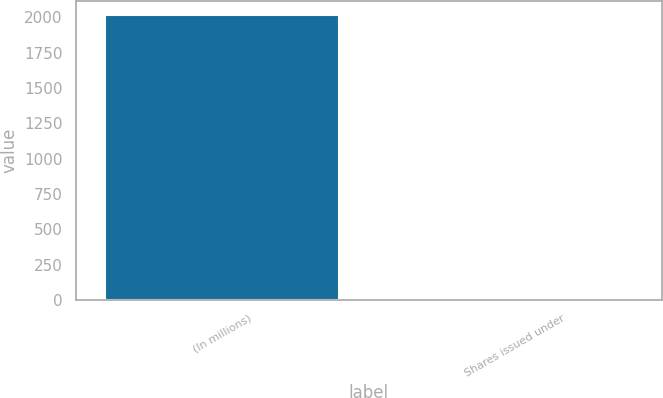Convert chart to OTSL. <chart><loc_0><loc_0><loc_500><loc_500><bar_chart><fcel>(In millions)<fcel>Shares issued under<nl><fcel>2013<fcel>1<nl></chart> 